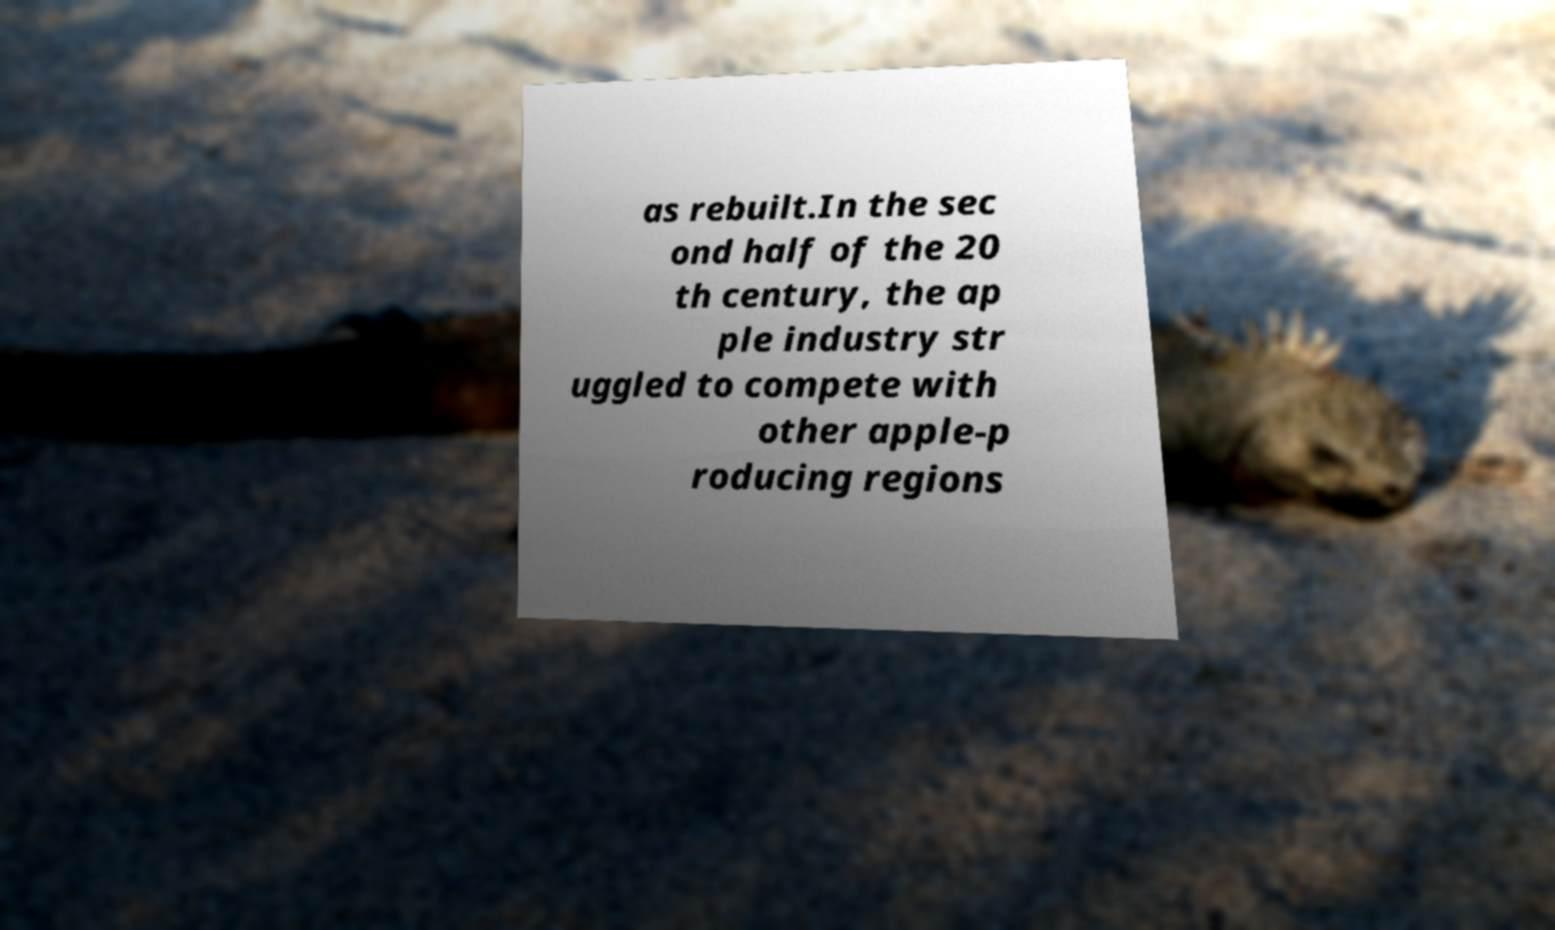What messages or text are displayed in this image? I need them in a readable, typed format. as rebuilt.In the sec ond half of the 20 th century, the ap ple industry str uggled to compete with other apple-p roducing regions 